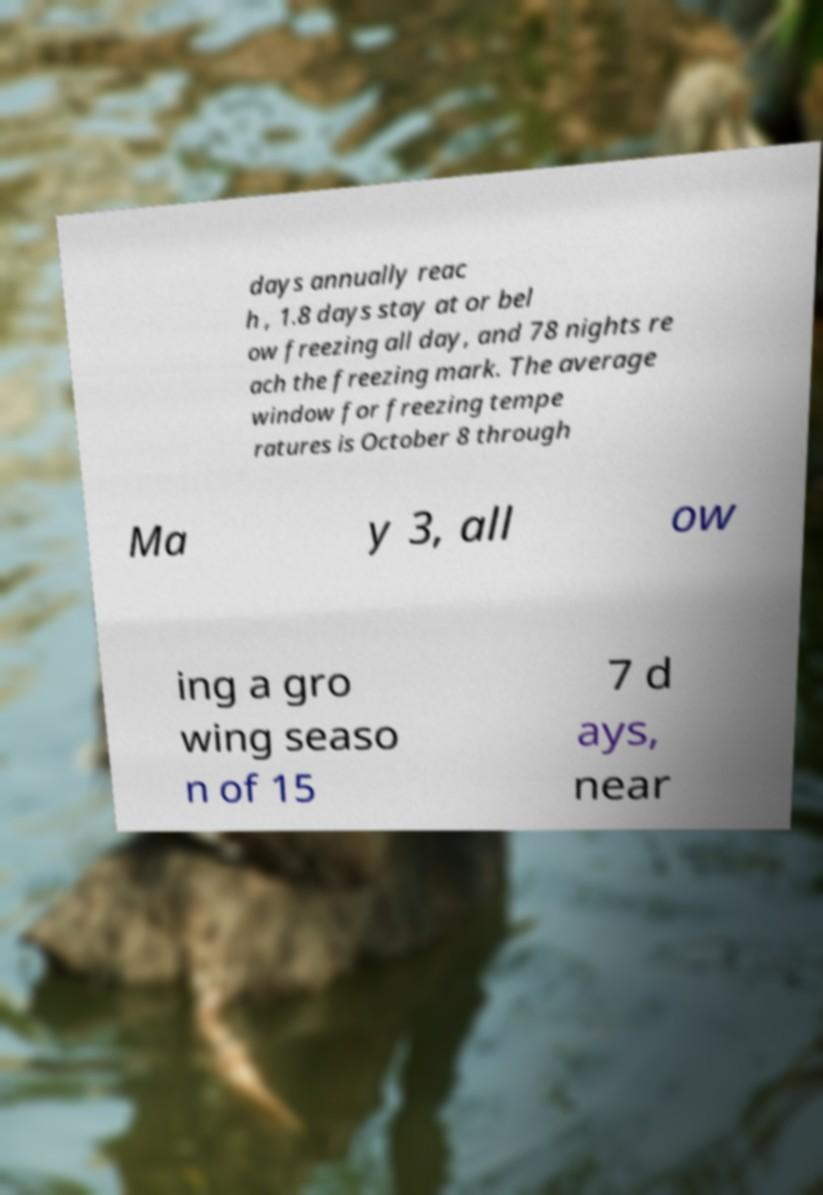Could you assist in decoding the text presented in this image and type it out clearly? days annually reac h , 1.8 days stay at or bel ow freezing all day, and 78 nights re ach the freezing mark. The average window for freezing tempe ratures is October 8 through Ma y 3, all ow ing a gro wing seaso n of 15 7 d ays, near 